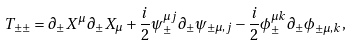<formula> <loc_0><loc_0><loc_500><loc_500>T _ { \pm \pm } = \partial _ { \pm } X ^ { \mu } \partial _ { \pm } X _ { \mu } + \frac { i } { 2 } \psi ^ { \mu j } _ { \pm } \partial _ { \pm } \psi _ { \pm \mu , j } - \frac { i } { 2 } \phi _ { \pm } ^ { \mu k } \partial _ { \pm } \phi _ { \pm \mu , k } ,</formula> 